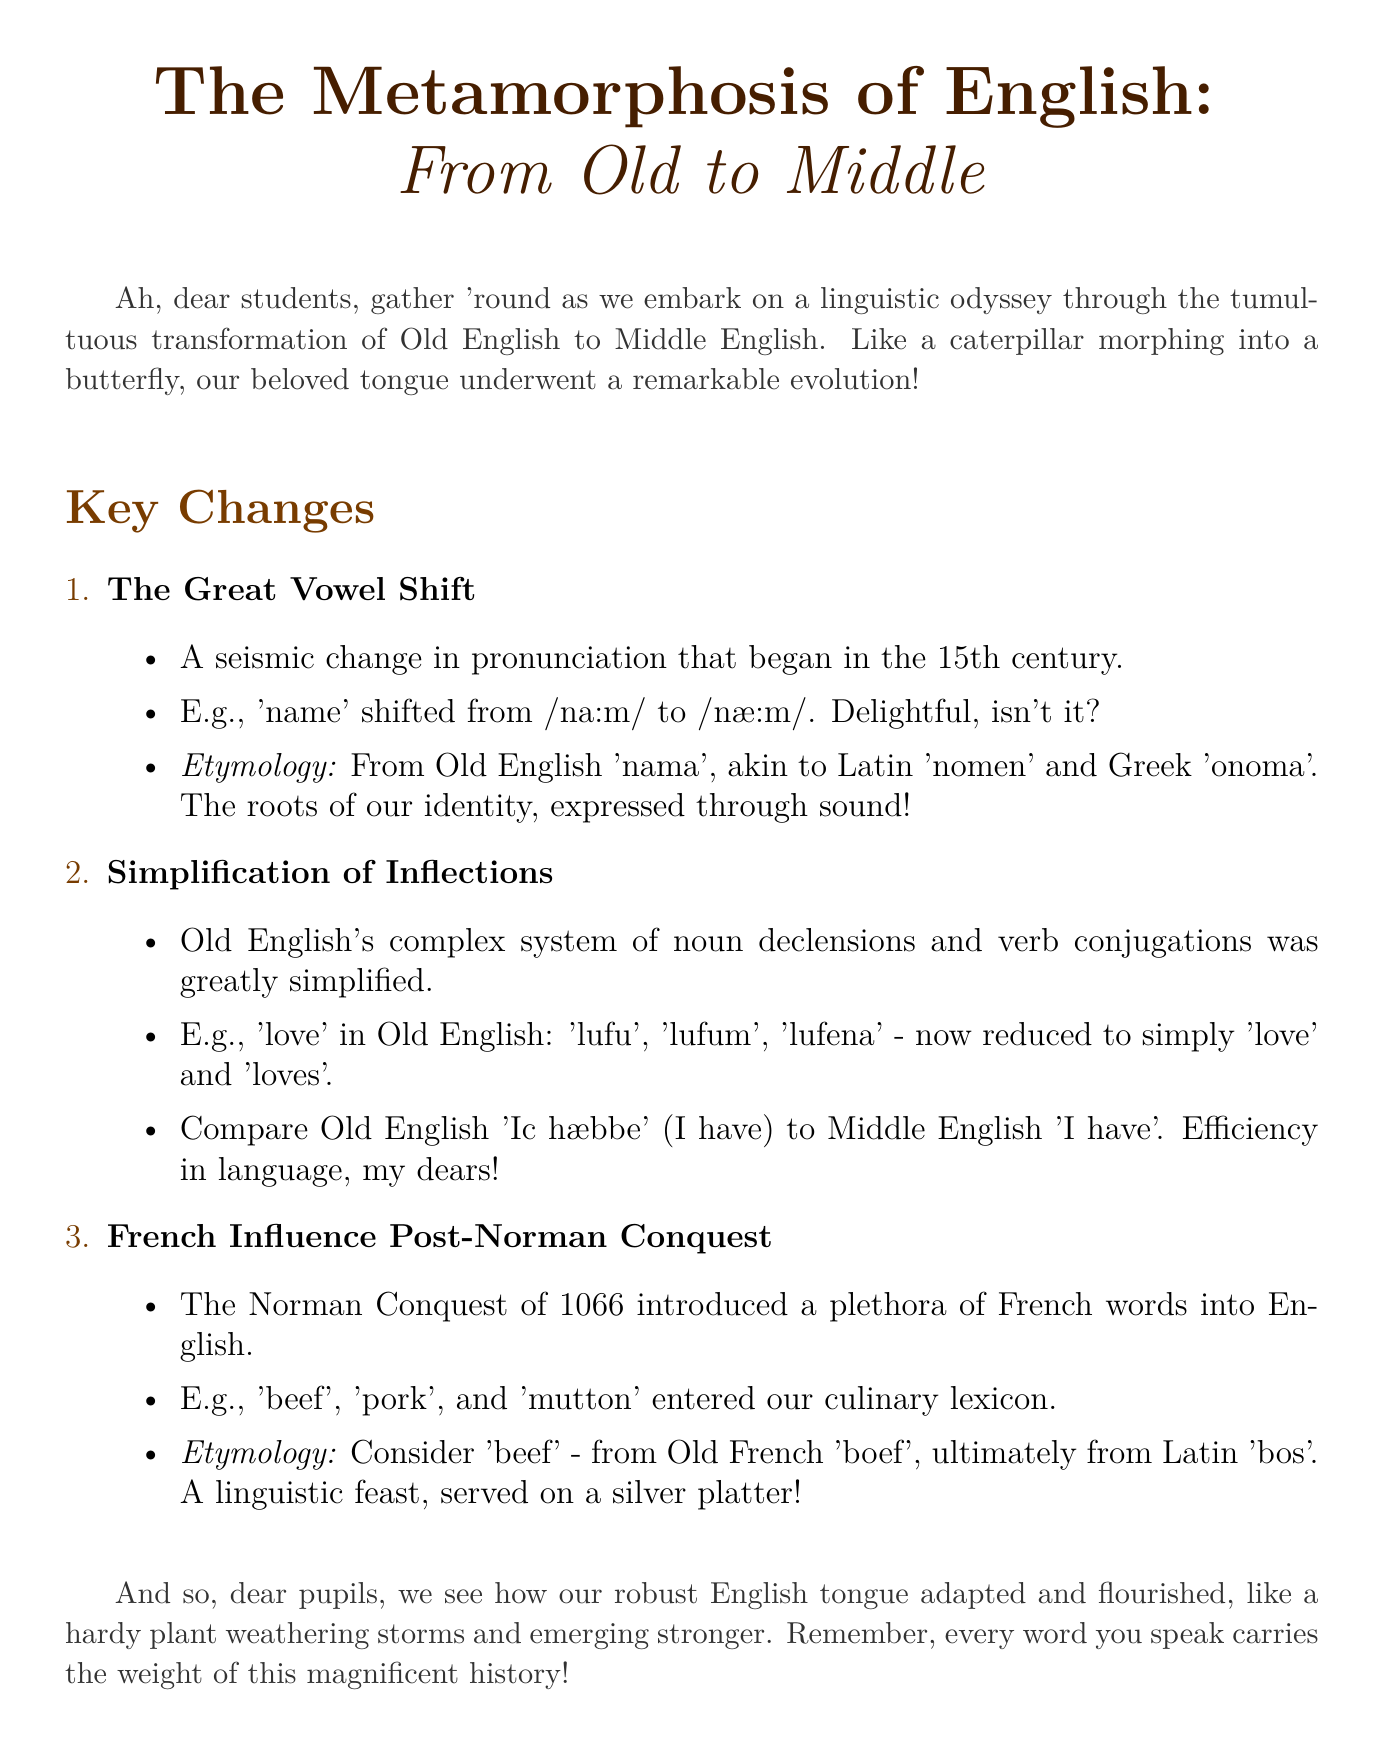What is the title of the document? The title is explicitly stated at the beginning of the document.
Answer: The Metamorphosis of English: From Old to Middle What is the key change that began in the 15th century? The document mentions a specific linguistic change that started during this period.
Answer: The Great Vowel Shift What example is given for the simplification of inflections? An example of a word showing this change is provided in the document.
Answer: love Which conquest introduced a plethora of French words into English? The document identifies a specific historical event that led to this linguistic influence.
Answer: Norman Conquest What is the etymology of the word 'beef'? The document provides the linguistic origins of this culinary term.
Answer: Old French boef How did Old English 'Ic hæbbe' translate to Middle English? A direct comparison is provided to illustrate this transformation.
Answer: I have What culinary terms entered English as a result of the Norman influence? The document lists specific words that were adopted into English from French.
Answer: beef, pork, mutton What metaphor is used to describe the evolution of the English language? A vivid figurative language is used in the introduction to illustrate linguistic evolution.
Answer: caterpillar morphing into a butterfly 